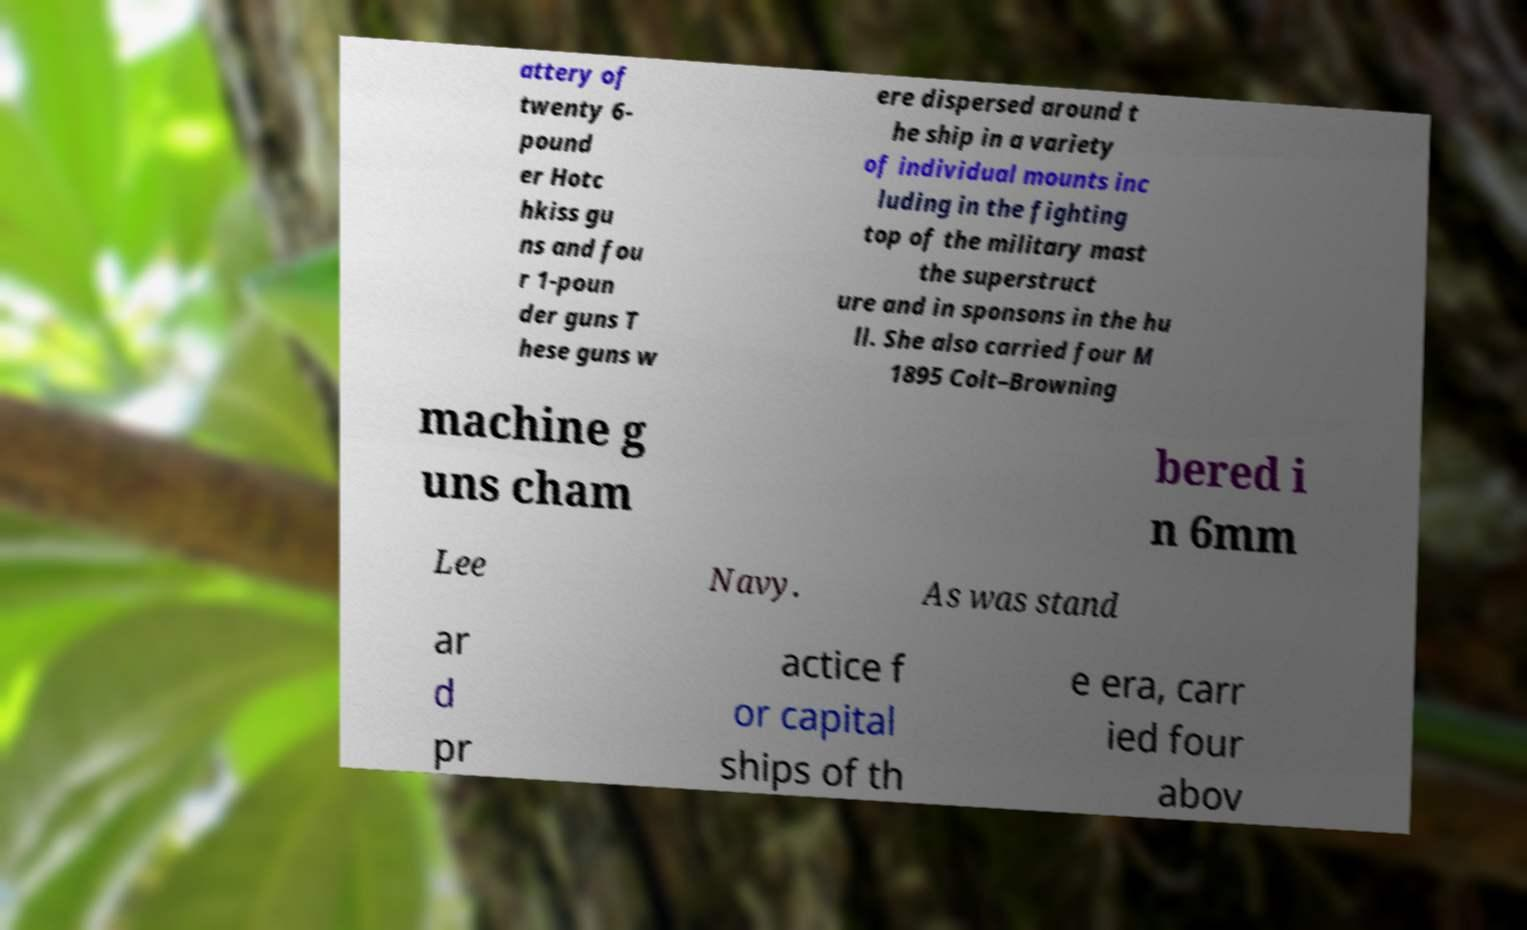Can you read and provide the text displayed in the image?This photo seems to have some interesting text. Can you extract and type it out for me? attery of twenty 6- pound er Hotc hkiss gu ns and fou r 1-poun der guns T hese guns w ere dispersed around t he ship in a variety of individual mounts inc luding in the fighting top of the military mast the superstruct ure and in sponsons in the hu ll. She also carried four M 1895 Colt–Browning machine g uns cham bered i n 6mm Lee Navy. As was stand ar d pr actice f or capital ships of th e era, carr ied four abov 